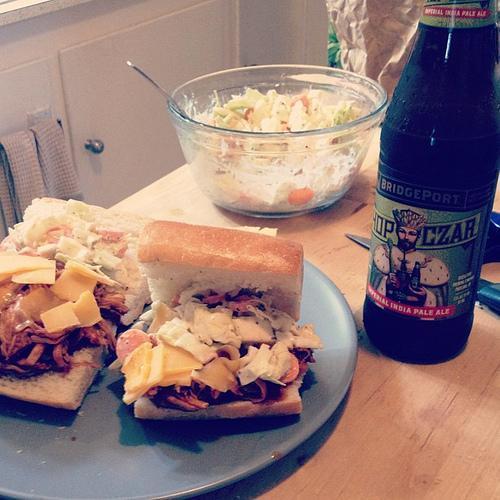How many sandwiches are there?
Give a very brief answer. 2. 